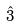<formula> <loc_0><loc_0><loc_500><loc_500>\hat { 3 }</formula> 